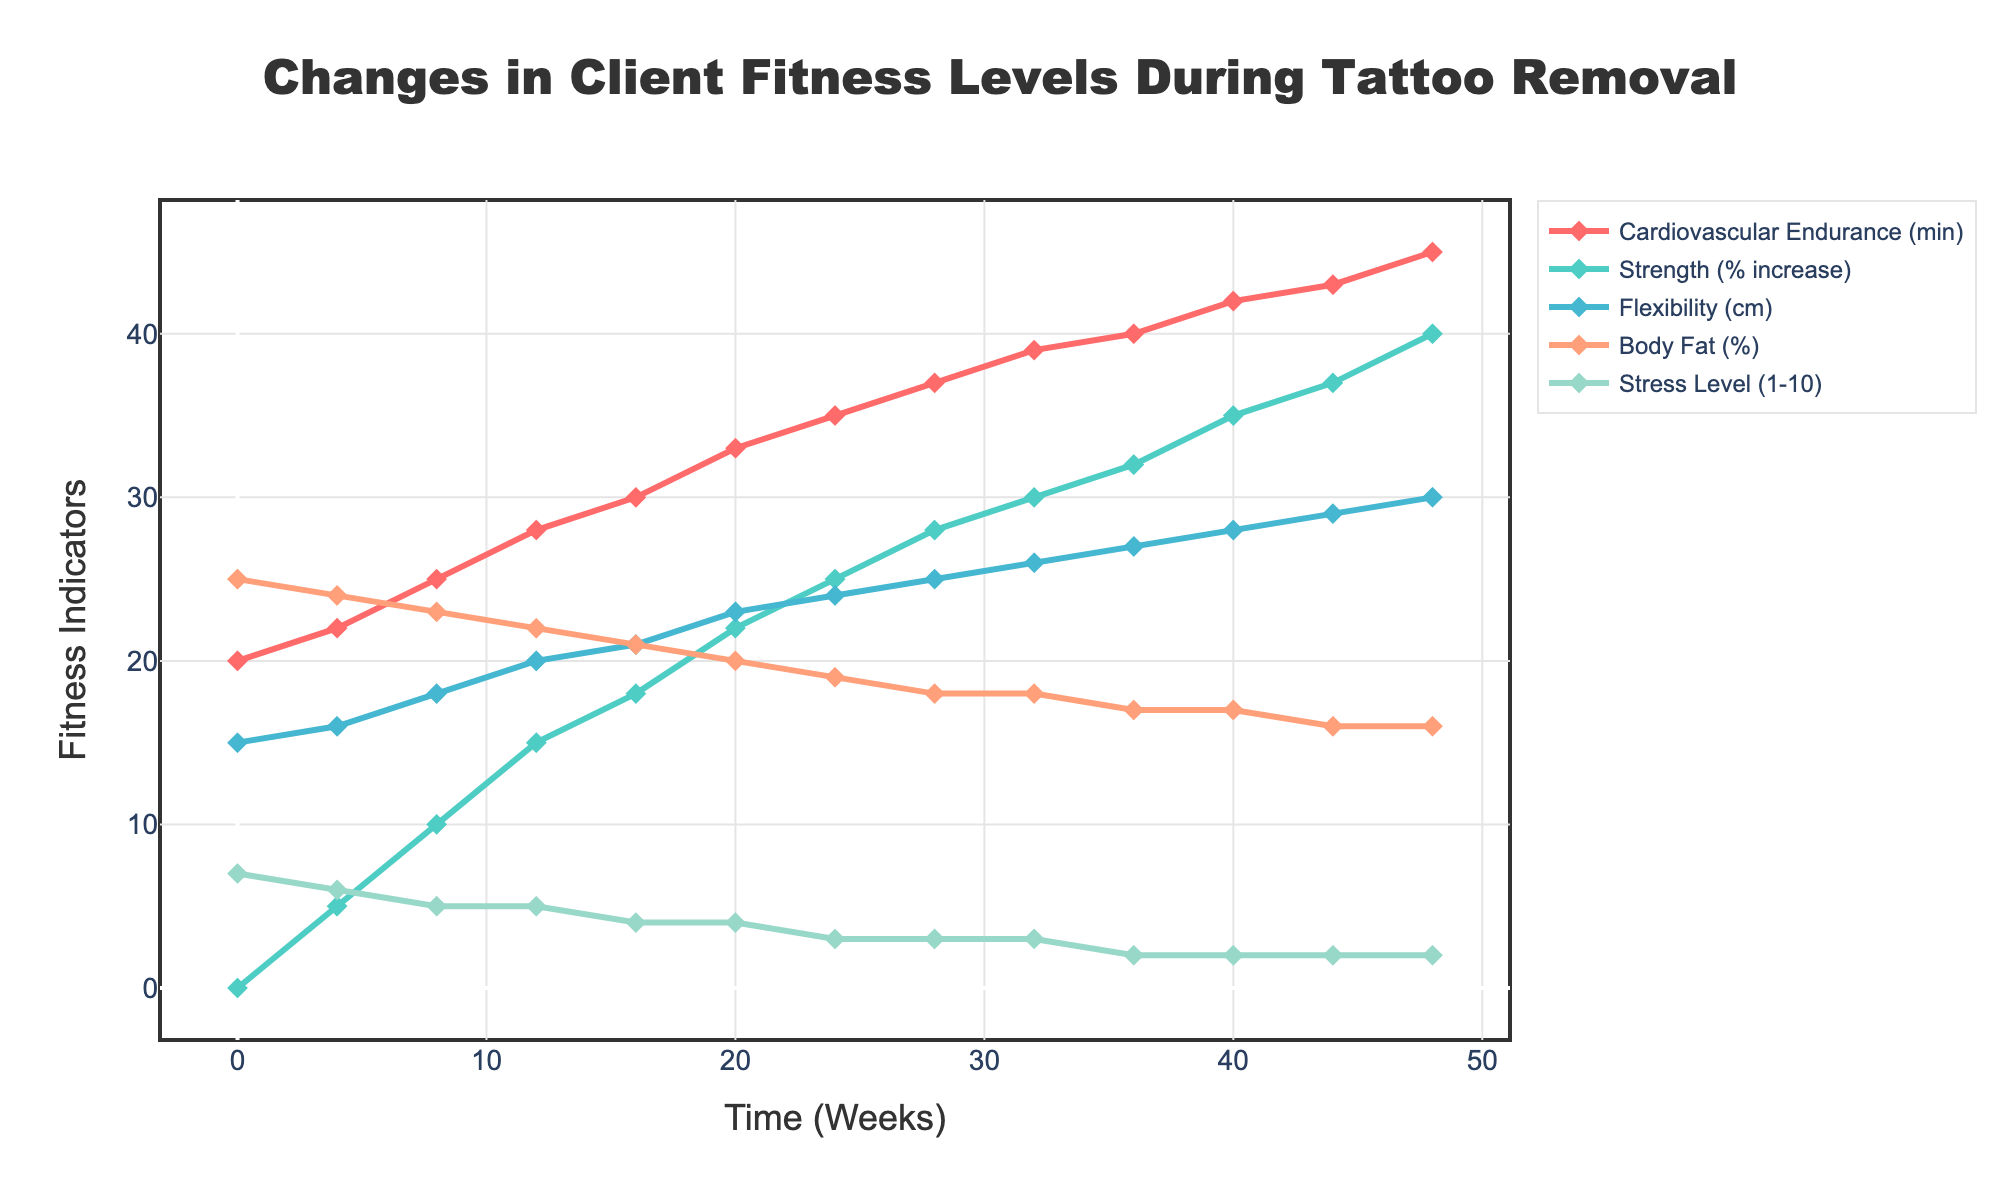What is the trend for Cardiovascular Endurance from week 0 to week 48? Cardiovascular Endurance shows a consistent upward trend from 20 minutes at week 0 to 45 minutes at week 48. This indicates a continuous improvement in this fitness indicator over time.
Answer: Continuous upward trend How does the Body Fat percentage change from the start to the end of the tattoo removal process? The Body Fat percentage decreases from 25% at week 0 to 16% at week 48. The decrease is consistent over the period, indicating effective fat loss.
Answer: Decreases from 25% to 16% Which fitness indicator shows the greatest increase in value over the 48 weeks? To determine this, we calculate the difference between the final and initial values for each indicator. The greatest increase is observed in Cardiovascular Endurance, which increases by 25 minutes (from 20 to 45 minutes).
Answer: Cardiovascular Endurance Between weeks 20 and 28, which fitness indicator shows the sharpest increase? By examining the changes:  
- Cardiovascular Endurance increases from 33 to 37 minutes (4 minutes).
- Strength increases from 22% to 28% (6%).
- Flexibility increases from 23 cm to 25 cm (2 cm).
- Body Fat percentage decreases from 20% to 18% (2%).
- Stress Level remains the same at 3.   
Strength shows the sharpest increase of 6%.
Answer: Strength Compare the stress levels at the beginning and at the end of the period. What trend do you observe? Stress Level decreases from 7 at week 0 to 2 at week 48. This indicates a significant reduction in stress over the period.
Answer: Decreasing trend At which week does Strength achieve a 20% increase from its initial value? To find this, look at the 'Strength (% increase)' line. Strength is above 20% starting at week 20, where it reaches a 22% increase.
Answer: Week 20 How do the Flexibility and Cardiovascular Endurance indicators compare at week 24? At week 24, Flexibility is 24 cm and Cardiovascular Endurance is 35 minutes. Comparing these values, Cardiovascular Endurance is significantly higher relative to its scale.
Answer: Cardiovascular Endurance is higher What is the average value of Flexibility from week 0 to week 48? The Flexibility values are 15, 16, 18, 20, 21, 23, 24, 25, 26, 27, 28, 29, 30. Summing these: 322 cm. There are 13 data points, so the average is 322 cm / 13 ≈ 24.77 cm.
Answer: ≈ 24.77 cm Identify any fitness indicators that show a plateau in their values during the presented weeks. Stress Level shows a plateau from week 16 to 32 at level 3 and from week 36 at level 2. Flexibility increases steadily without any plateau. Body Fat reduces continuously without plateau.
Answer: Stress Level 